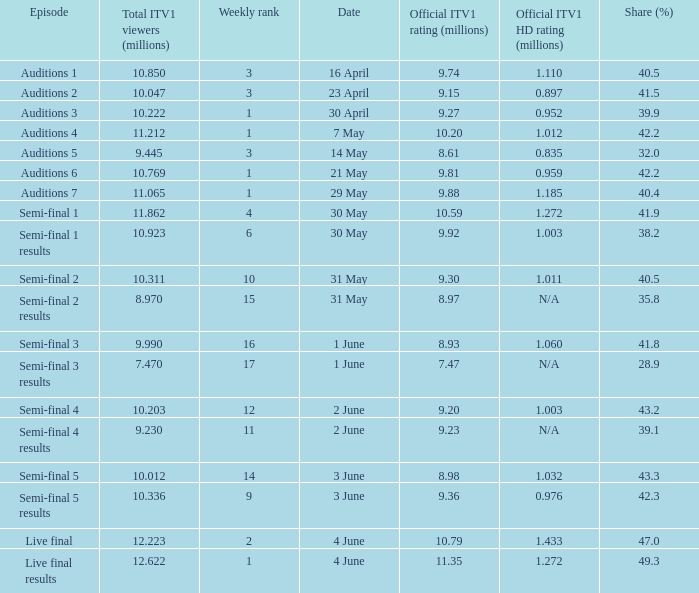What was the official ITV1 HD rating in millions for the episode that had an official ITV1 rating of 8.98 million? 1.032. 